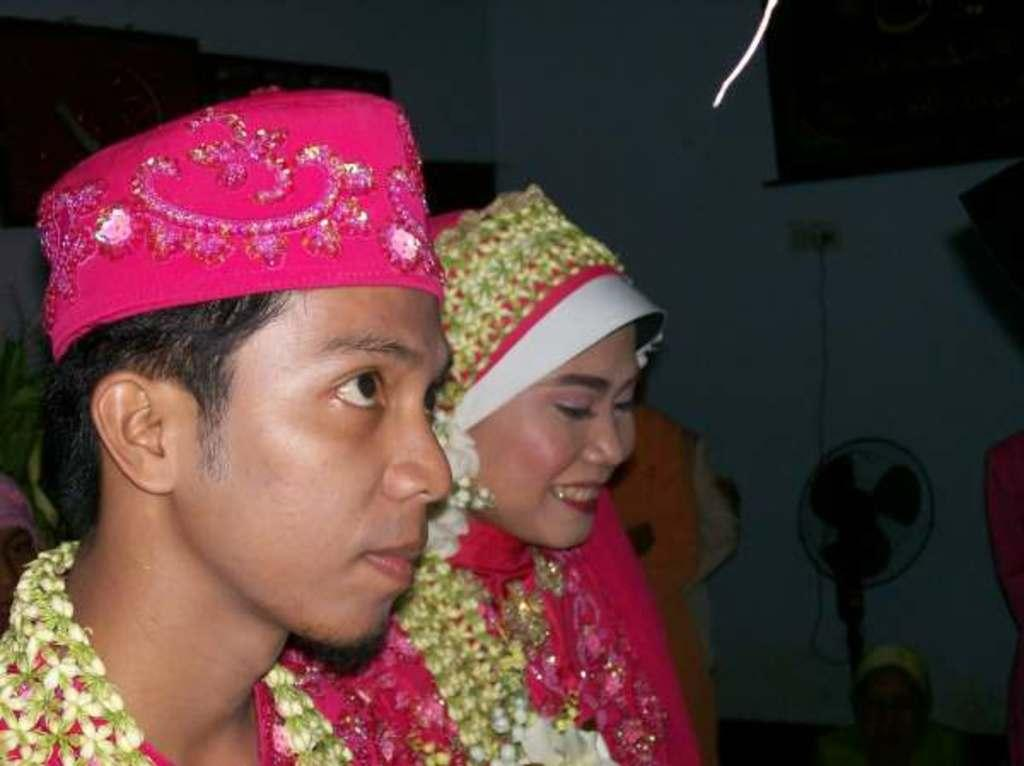Who are the main subjects in the image? There is a bride and a bridegroom in the image. What can be observed about the bridegroom's attire? The bridegroom is wearing a cap. What is visible in the background of the image? There is a wall in the background of the image. Can you describe any additional objects in the background? There is a fan near the wall in the background. What type of silver rule does the governor enforce in the image? There is no mention of a governor or a rule in the image; it features a bride and bridegroom. 